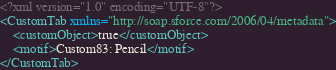<code> <loc_0><loc_0><loc_500><loc_500><_XML_><?xml version="1.0" encoding="UTF-8"?>
<CustomTab xmlns="http://soap.sforce.com/2006/04/metadata">
    <customObject>true</customObject>
    <motif>Custom83: Pencil</motif>
</CustomTab>
</code> 